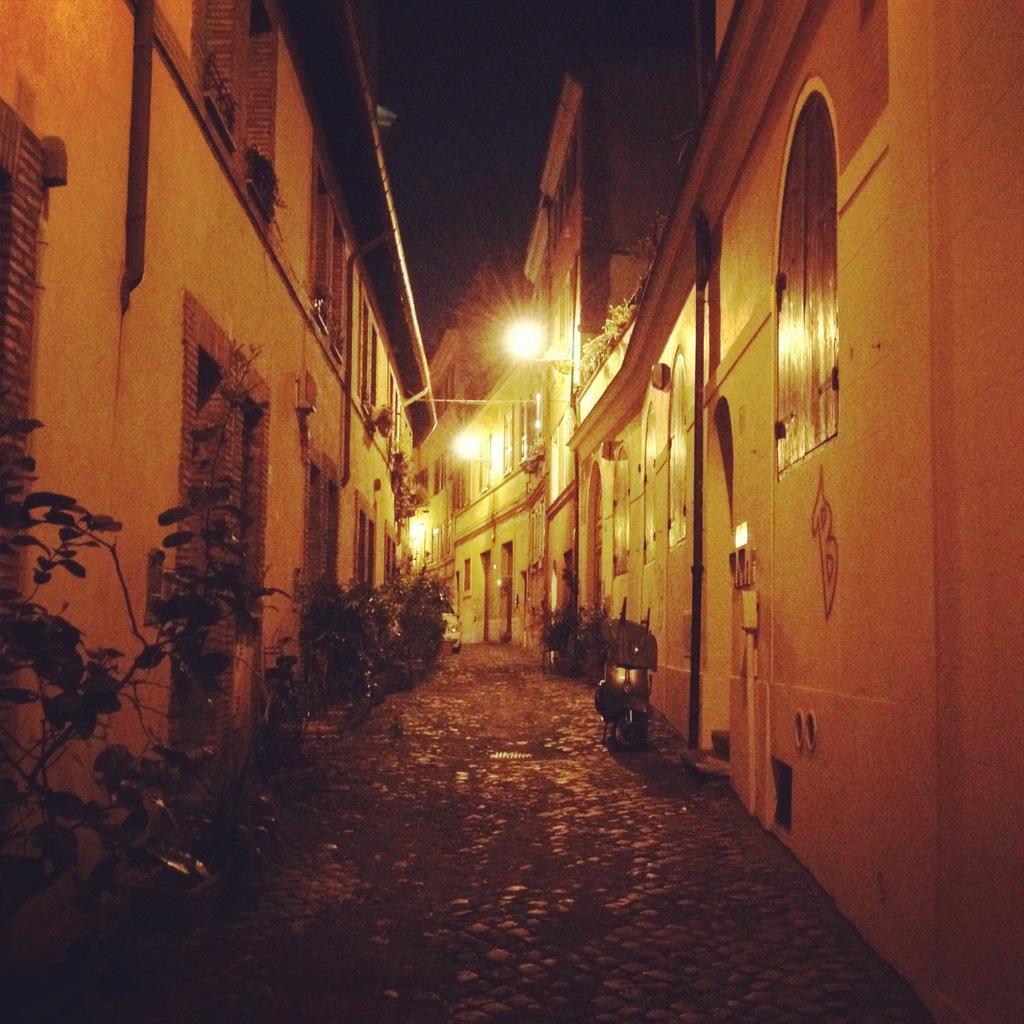Please provide a concise description of this image. These are the buildings with the windows and doors. I can see the plants. This looks like a motorbike, which is parked. I think this is a street. These are the lights. 